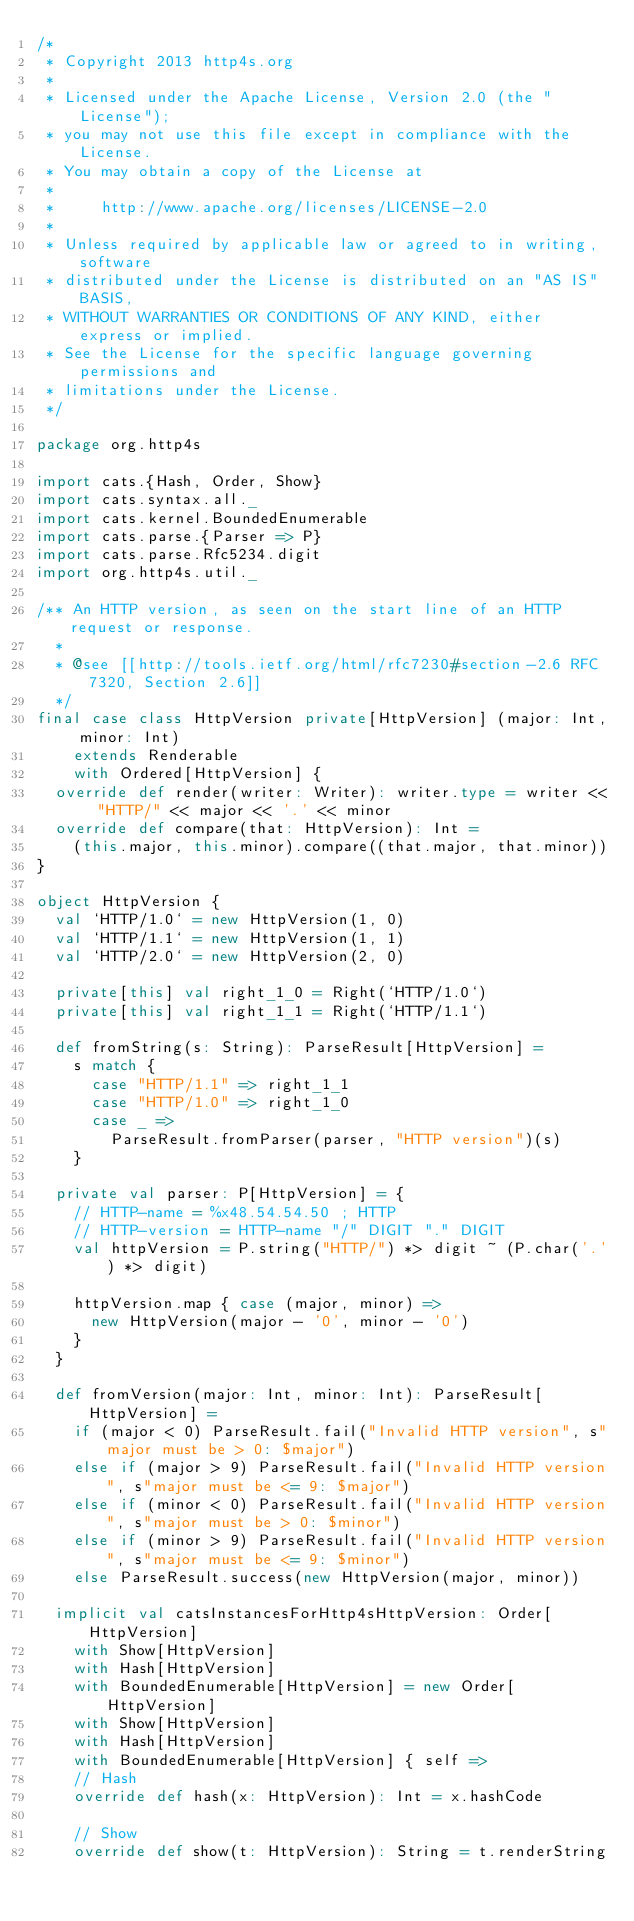<code> <loc_0><loc_0><loc_500><loc_500><_Scala_>/*
 * Copyright 2013 http4s.org
 *
 * Licensed under the Apache License, Version 2.0 (the "License");
 * you may not use this file except in compliance with the License.
 * You may obtain a copy of the License at
 *
 *     http://www.apache.org/licenses/LICENSE-2.0
 *
 * Unless required by applicable law or agreed to in writing, software
 * distributed under the License is distributed on an "AS IS" BASIS,
 * WITHOUT WARRANTIES OR CONDITIONS OF ANY KIND, either express or implied.
 * See the License for the specific language governing permissions and
 * limitations under the License.
 */

package org.http4s

import cats.{Hash, Order, Show}
import cats.syntax.all._
import cats.kernel.BoundedEnumerable
import cats.parse.{Parser => P}
import cats.parse.Rfc5234.digit
import org.http4s.util._

/** An HTTP version, as seen on the start line of an HTTP request or response.
  *
  * @see [[http://tools.ietf.org/html/rfc7230#section-2.6 RFC 7320, Section 2.6]]
  */
final case class HttpVersion private[HttpVersion] (major: Int, minor: Int)
    extends Renderable
    with Ordered[HttpVersion] {
  override def render(writer: Writer): writer.type = writer << "HTTP/" << major << '.' << minor
  override def compare(that: HttpVersion): Int =
    (this.major, this.minor).compare((that.major, that.minor))
}

object HttpVersion {
  val `HTTP/1.0` = new HttpVersion(1, 0)
  val `HTTP/1.1` = new HttpVersion(1, 1)
  val `HTTP/2.0` = new HttpVersion(2, 0)

  private[this] val right_1_0 = Right(`HTTP/1.0`)
  private[this] val right_1_1 = Right(`HTTP/1.1`)

  def fromString(s: String): ParseResult[HttpVersion] =
    s match {
      case "HTTP/1.1" => right_1_1
      case "HTTP/1.0" => right_1_0
      case _ =>
        ParseResult.fromParser(parser, "HTTP version")(s)
    }

  private val parser: P[HttpVersion] = {
    // HTTP-name = %x48.54.54.50 ; HTTP
    // HTTP-version = HTTP-name "/" DIGIT "." DIGIT
    val httpVersion = P.string("HTTP/") *> digit ~ (P.char('.') *> digit)

    httpVersion.map { case (major, minor) =>
      new HttpVersion(major - '0', minor - '0')
    }
  }

  def fromVersion(major: Int, minor: Int): ParseResult[HttpVersion] =
    if (major < 0) ParseResult.fail("Invalid HTTP version", s"major must be > 0: $major")
    else if (major > 9) ParseResult.fail("Invalid HTTP version", s"major must be <= 9: $major")
    else if (minor < 0) ParseResult.fail("Invalid HTTP version", s"major must be > 0: $minor")
    else if (minor > 9) ParseResult.fail("Invalid HTTP version", s"major must be <= 9: $minor")
    else ParseResult.success(new HttpVersion(major, minor))

  implicit val catsInstancesForHttp4sHttpVersion: Order[HttpVersion]
    with Show[HttpVersion]
    with Hash[HttpVersion]
    with BoundedEnumerable[HttpVersion] = new Order[HttpVersion]
    with Show[HttpVersion]
    with Hash[HttpVersion]
    with BoundedEnumerable[HttpVersion] { self =>
    // Hash
    override def hash(x: HttpVersion): Int = x.hashCode

    // Show
    override def show(t: HttpVersion): String = t.renderString
</code> 